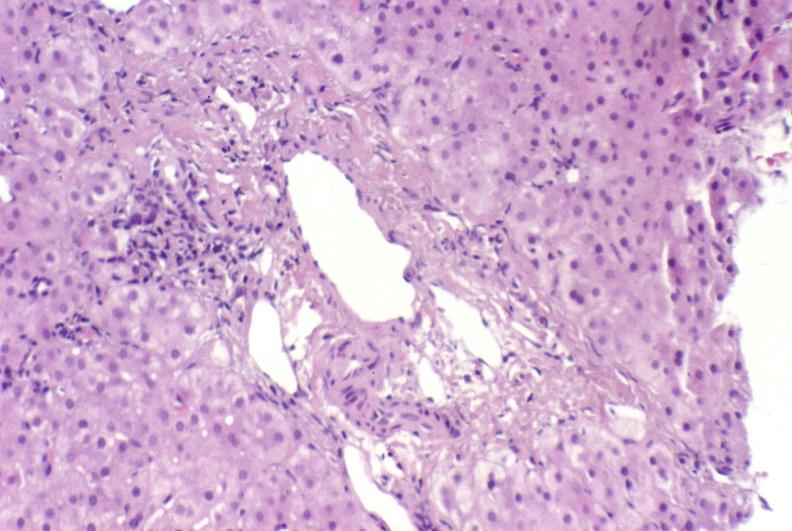what is present?
Answer the question using a single word or phrase. Liver 